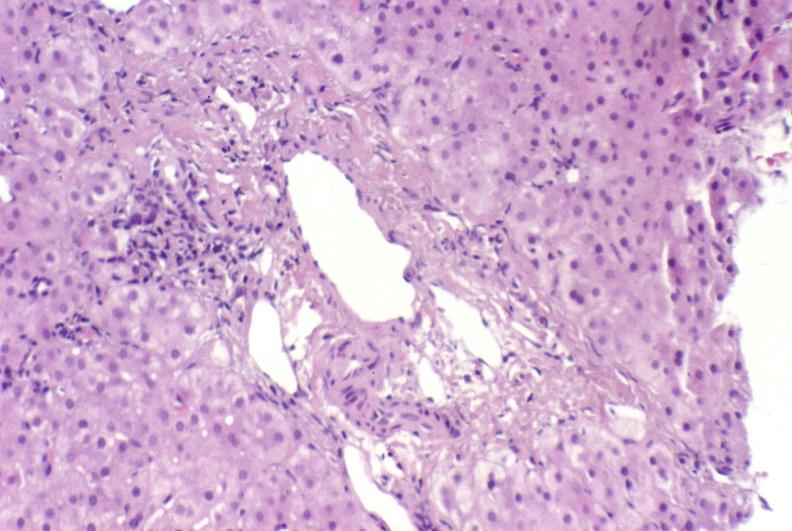what is present?
Answer the question using a single word or phrase. Liver 